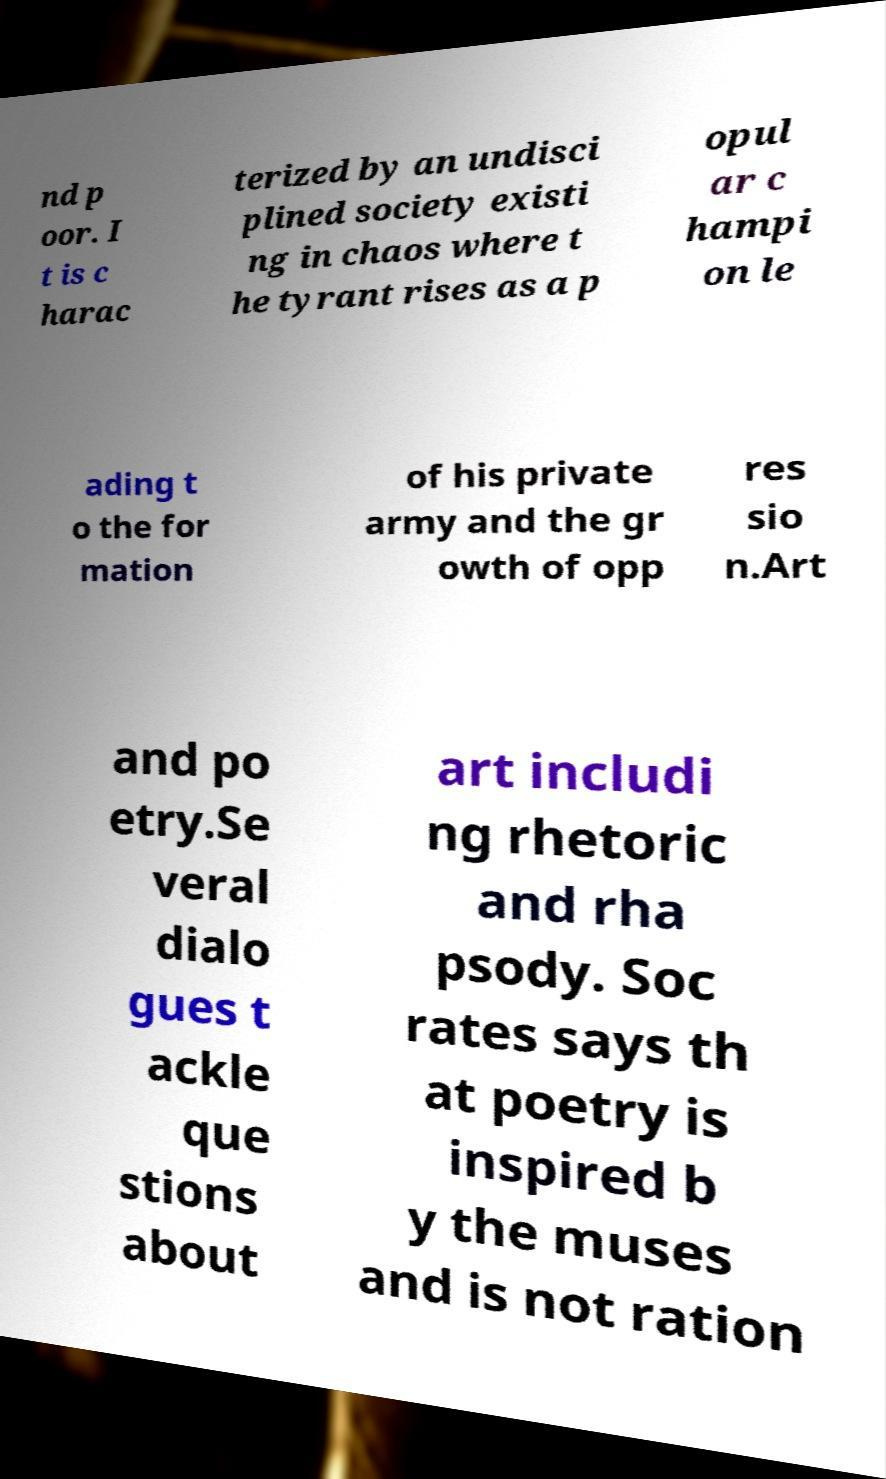I need the written content from this picture converted into text. Can you do that? nd p oor. I t is c harac terized by an undisci plined society existi ng in chaos where t he tyrant rises as a p opul ar c hampi on le ading t o the for mation of his private army and the gr owth of opp res sio n.Art and po etry.Se veral dialo gues t ackle que stions about art includi ng rhetoric and rha psody. Soc rates says th at poetry is inspired b y the muses and is not ration 